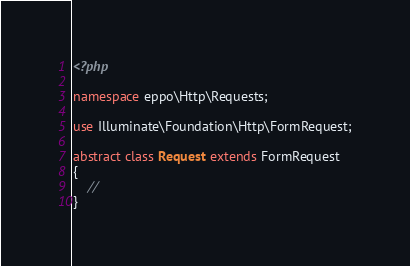<code> <loc_0><loc_0><loc_500><loc_500><_PHP_><?php

namespace eppo\Http\Requests;

use Illuminate\Foundation\Http\FormRequest;

abstract class Request extends FormRequest
{
    //
}
</code> 